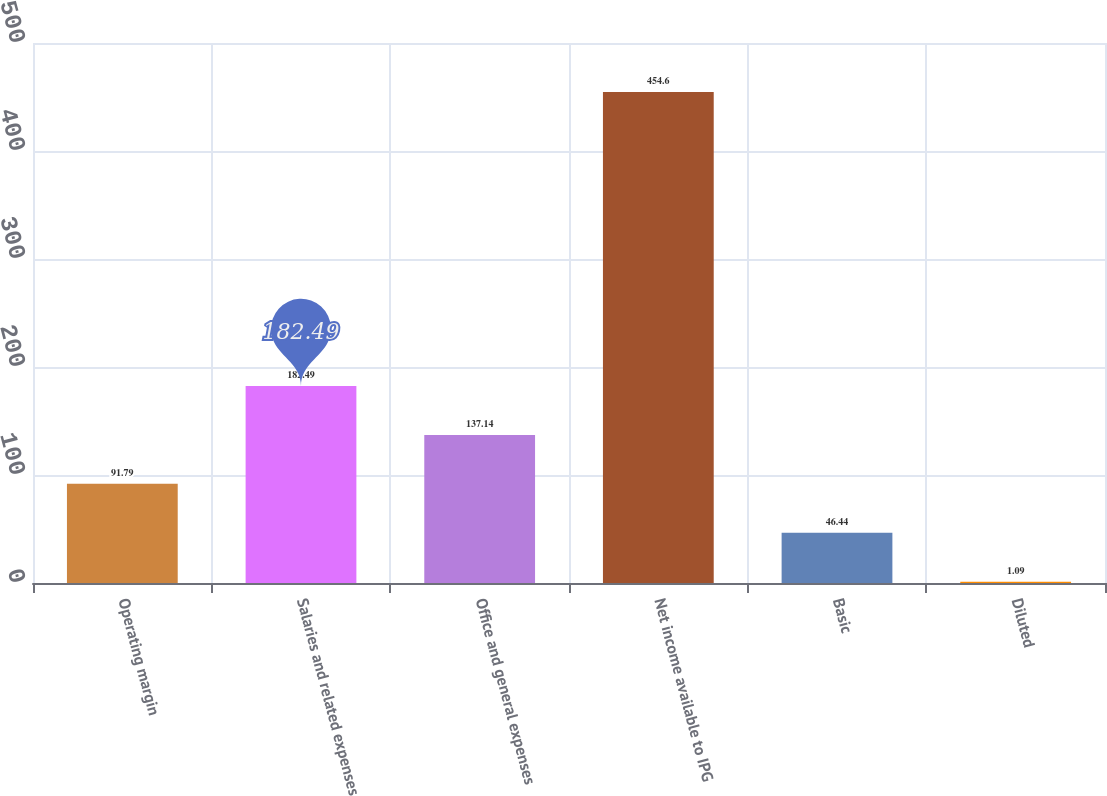Convert chart to OTSL. <chart><loc_0><loc_0><loc_500><loc_500><bar_chart><fcel>Operating margin<fcel>Salaries and related expenses<fcel>Office and general expenses<fcel>Net income available to IPG<fcel>Basic<fcel>Diluted<nl><fcel>91.79<fcel>182.49<fcel>137.14<fcel>454.6<fcel>46.44<fcel>1.09<nl></chart> 